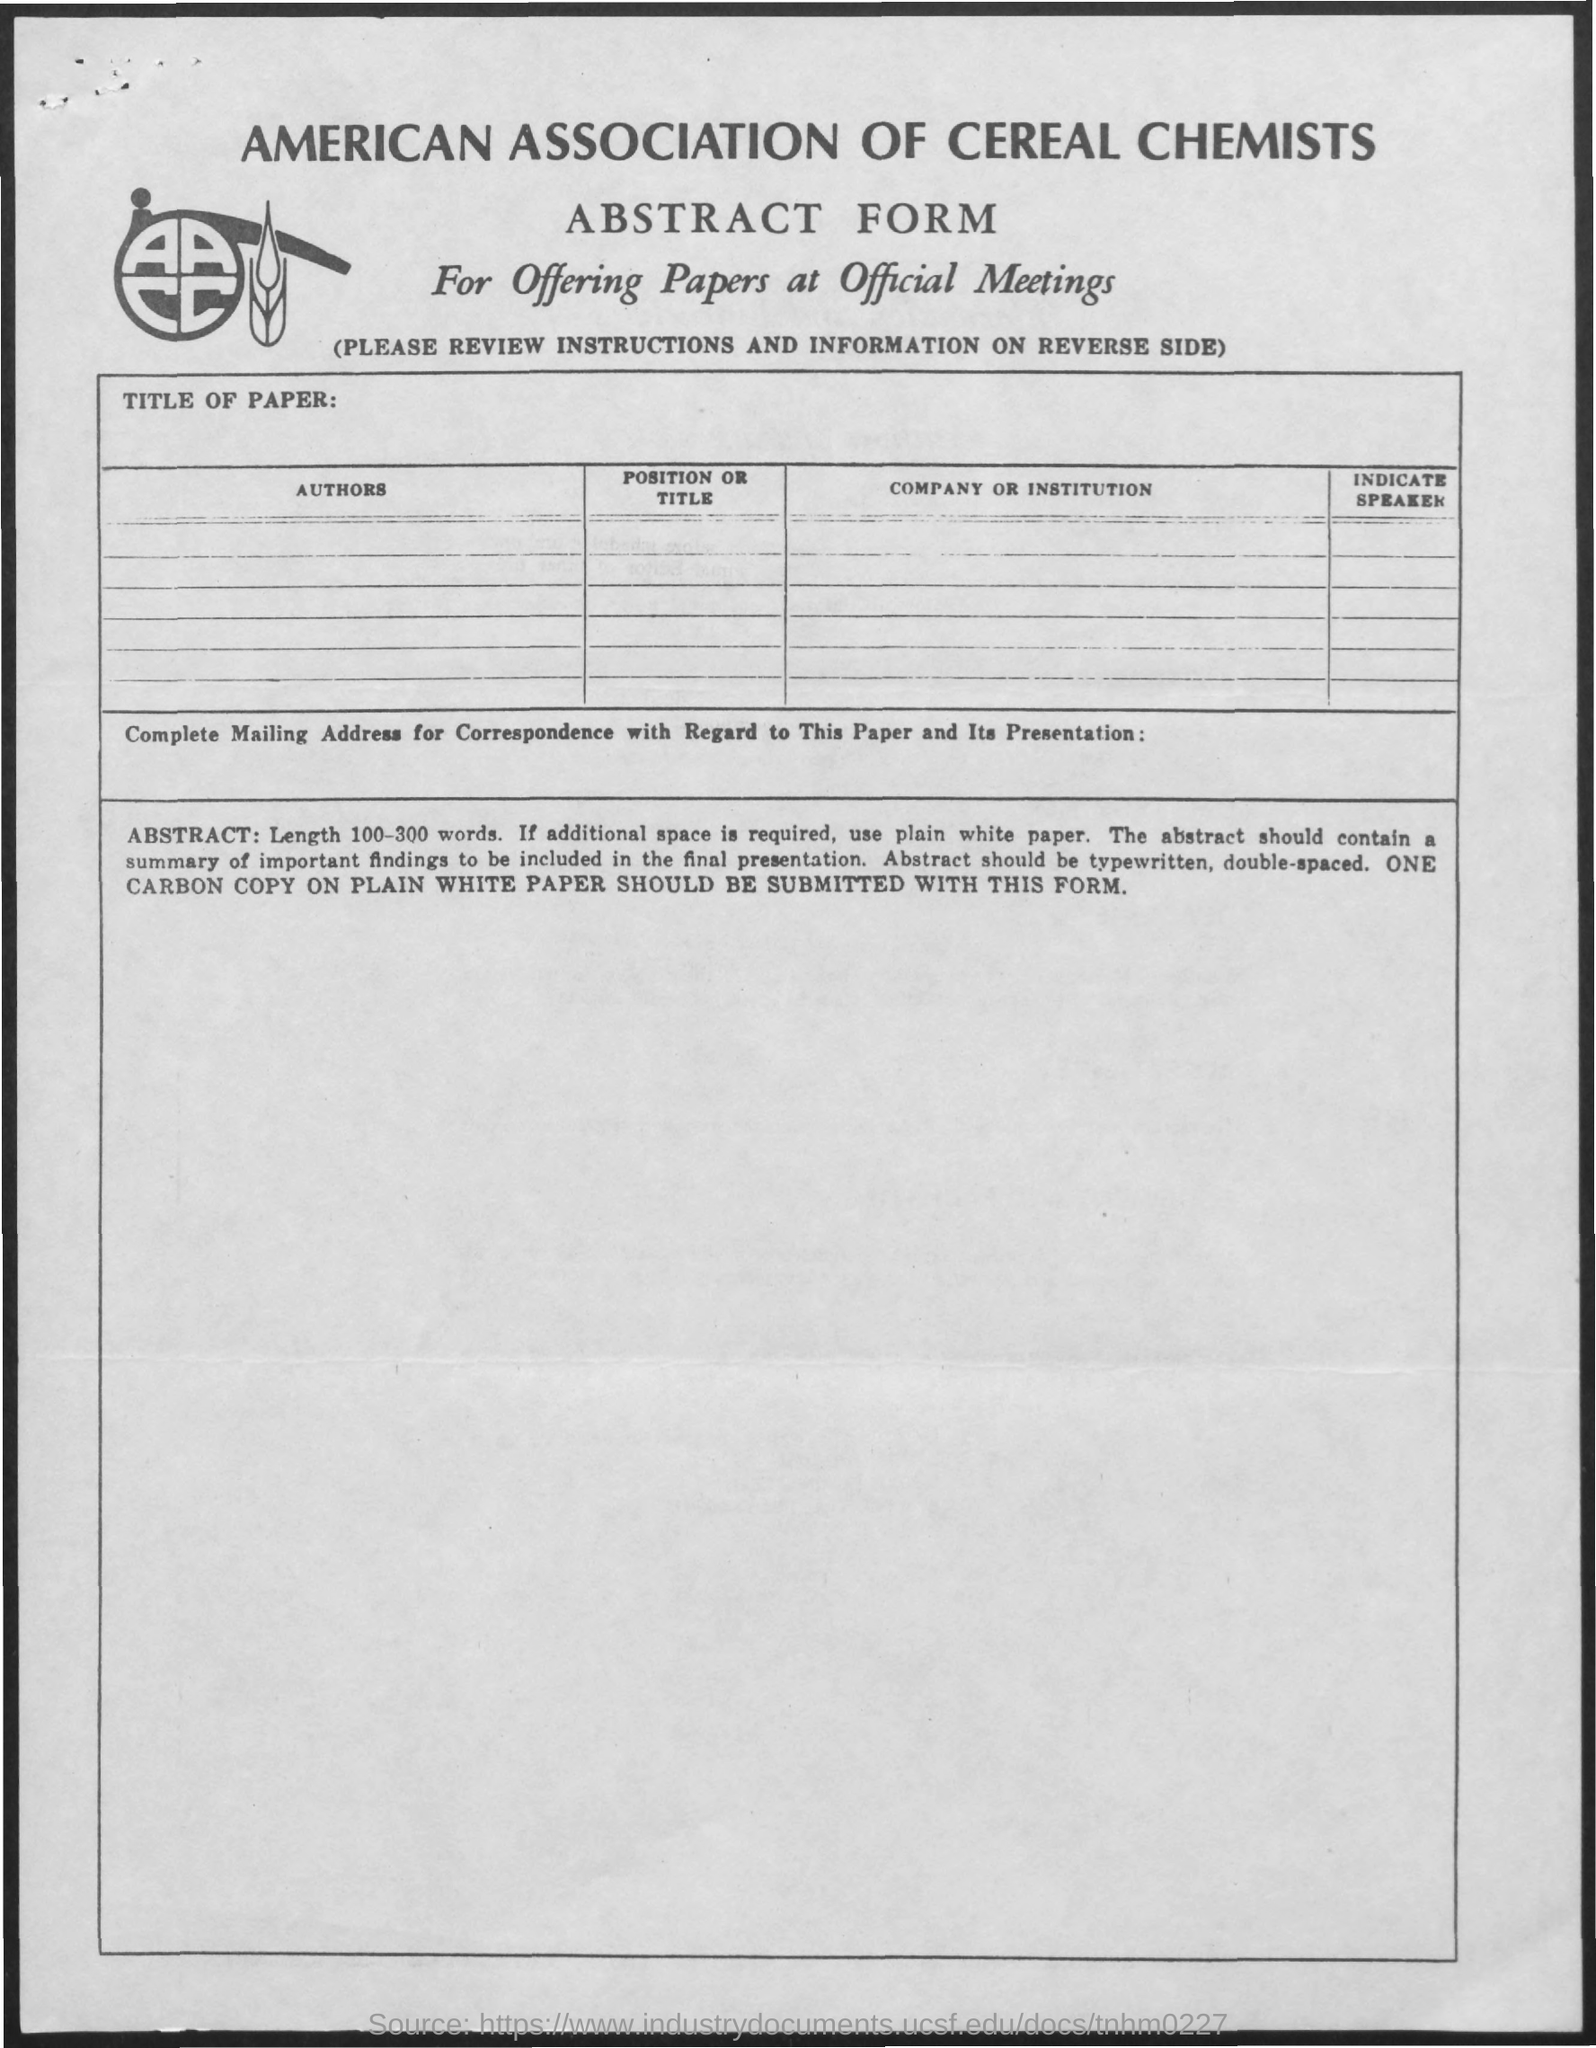Draw attention to some important aspects in this diagram. The American Association of Cereal Chemists (AACC) is a named association mentioned in the given form. The form mentioned in the given page is called the abstract form. 